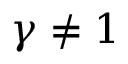Convert formula to latex. <formula><loc_0><loc_0><loc_500><loc_500>\gamma \neq 1</formula> 